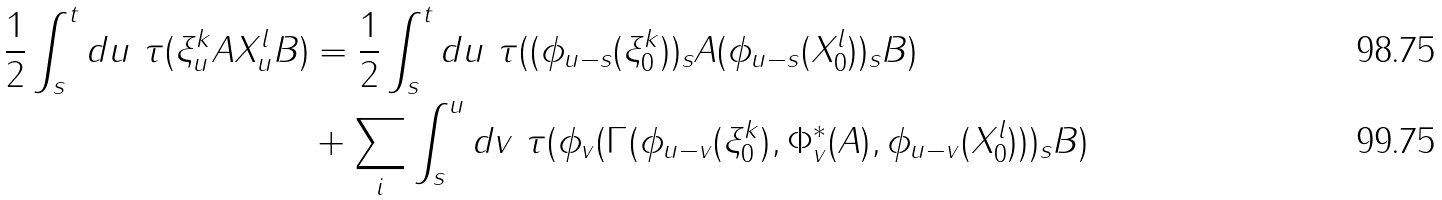Convert formula to latex. <formula><loc_0><loc_0><loc_500><loc_500>\frac { 1 } { 2 } \int _ { s } ^ { t } d u \ \tau ( \xi _ { u } ^ { k } A X _ { u } ^ { l } B ) & = \frac { 1 } { 2 } \int _ { s } ^ { t } d u \ \tau ( ( \phi _ { u - s } ( \xi _ { 0 } ^ { k } ) ) _ { s } A ( \phi _ { u - s } ( X _ { 0 } ^ { l } ) ) _ { s } B ) \\ & + \sum _ { i } \int _ { s } ^ { u } d v \ \tau ( \phi _ { v } ( \Gamma ( \phi _ { u - v } ( \xi _ { 0 } ^ { k } ) , \Phi ^ { * } _ { v } ( A ) , \phi _ { u - v } ( X _ { 0 } ^ { l } ) ) ) _ { s } B )</formula> 